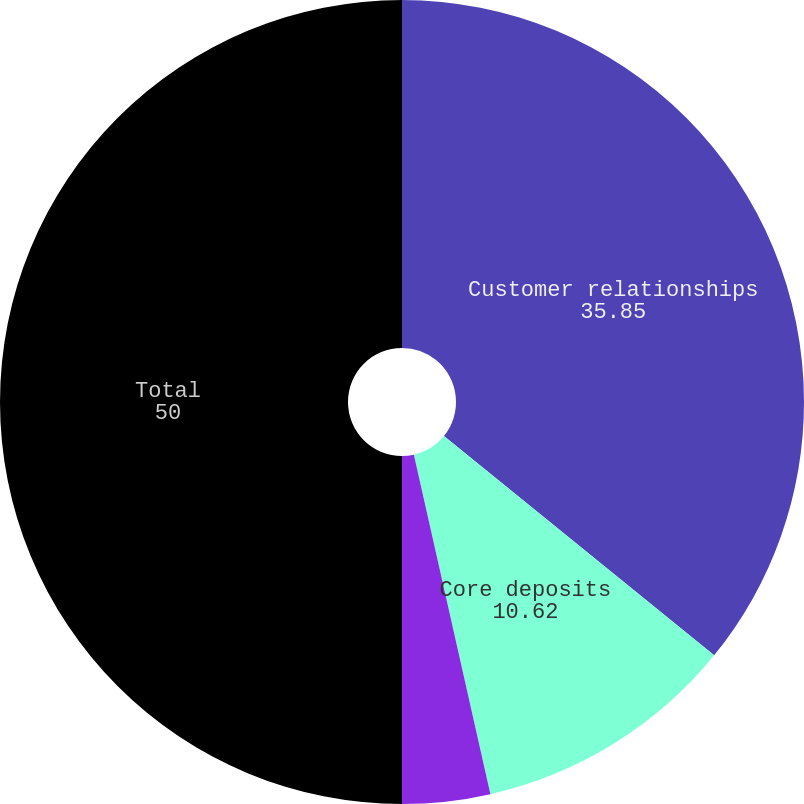<chart> <loc_0><loc_0><loc_500><loc_500><pie_chart><fcel>Customer relationships<fcel>Core deposits<fcel>Other<fcel>Total<nl><fcel>35.85%<fcel>10.62%<fcel>3.53%<fcel>50.0%<nl></chart> 